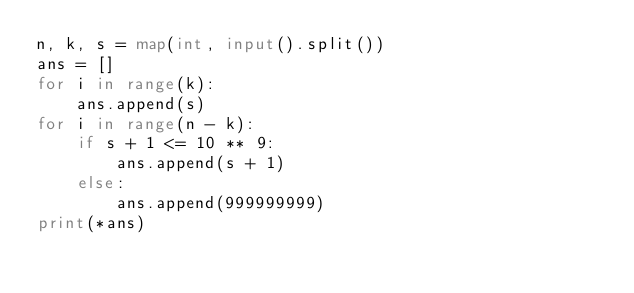Convert code to text. <code><loc_0><loc_0><loc_500><loc_500><_Python_>n, k, s = map(int, input().split())
ans = []
for i in range(k):
    ans.append(s)
for i in range(n - k):
    if s + 1 <= 10 ** 9:
        ans.append(s + 1)
    else:
        ans.append(999999999)
print(*ans)</code> 